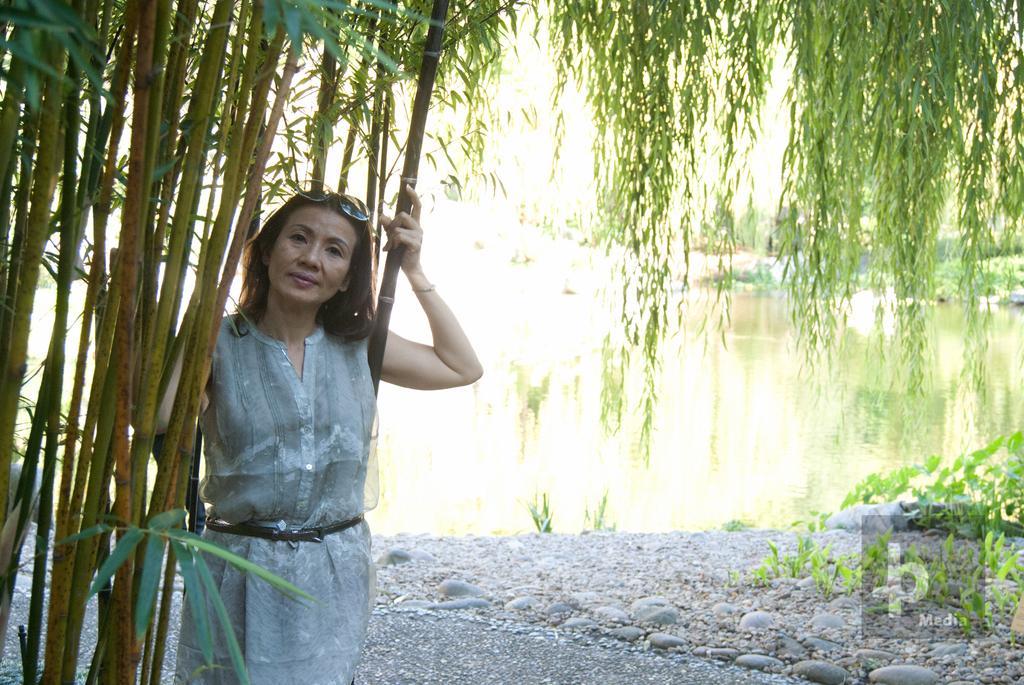In one or two sentences, can you explain what this image depicts? In this image we can see a lady person wearing white color dress and also goggles standing near the tree and in the background of the image there are some trees and water. 